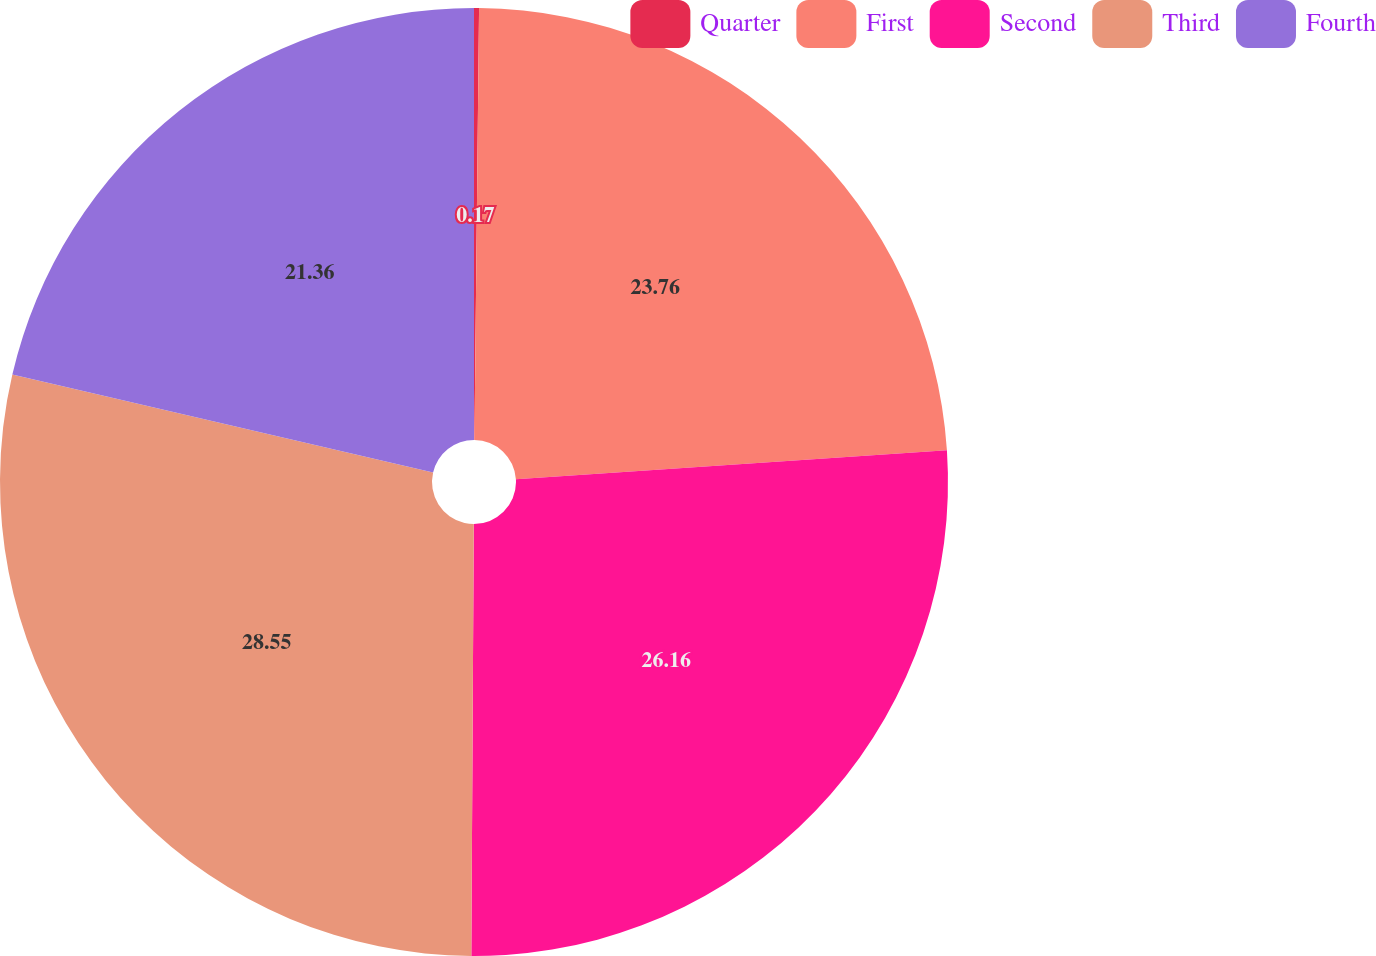<chart> <loc_0><loc_0><loc_500><loc_500><pie_chart><fcel>Quarter<fcel>First<fcel>Second<fcel>Third<fcel>Fourth<nl><fcel>0.17%<fcel>23.76%<fcel>26.16%<fcel>28.55%<fcel>21.36%<nl></chart> 